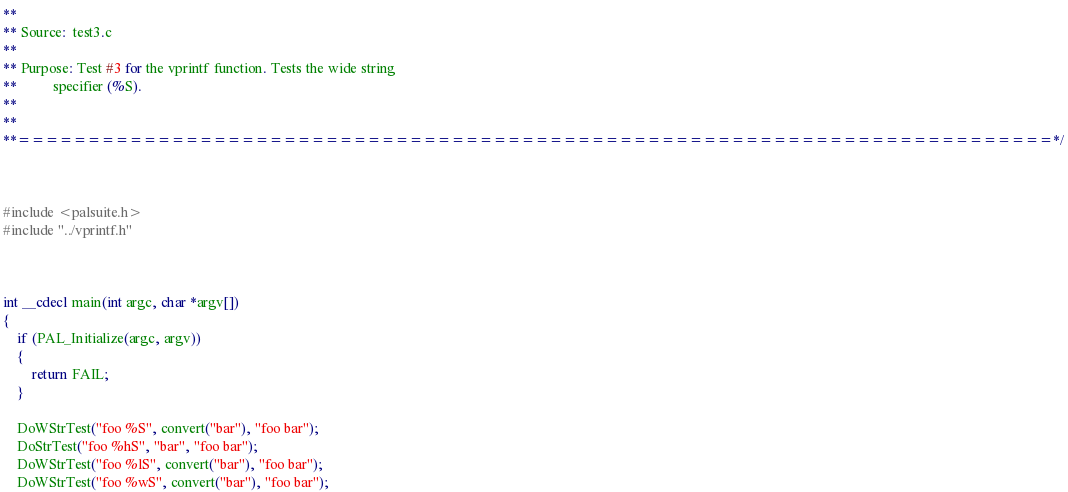Convert code to text. <code><loc_0><loc_0><loc_500><loc_500><_C++_>**
** Source:  test3.c
**
** Purpose: Test #3 for the vprintf function. Tests the wide string
**          specifier (%S).
**
**
**==========================================================================*/



#include <palsuite.h>
#include "../vprintf.h"



int __cdecl main(int argc, char *argv[])
{
    if (PAL_Initialize(argc, argv))
    {
        return FAIL;
    }

    DoWStrTest("foo %S", convert("bar"), "foo bar");
    DoStrTest("foo %hS", "bar", "foo bar");
    DoWStrTest("foo %lS", convert("bar"), "foo bar");
    DoWStrTest("foo %wS", convert("bar"), "foo bar");</code> 